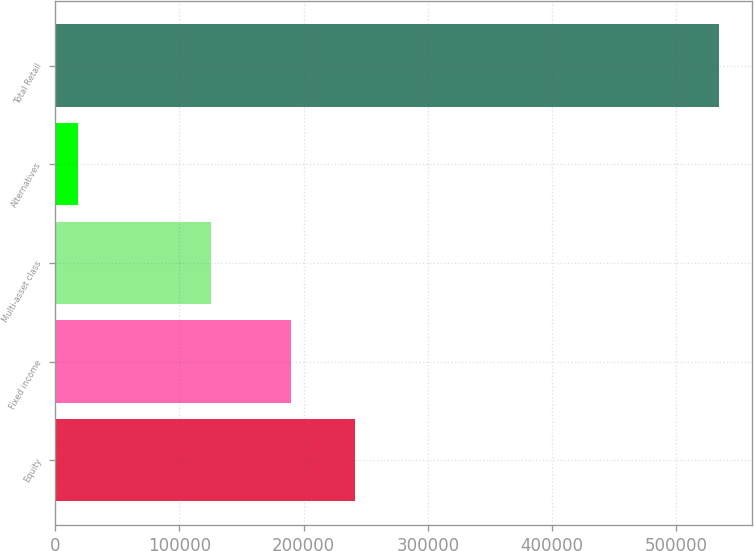<chart> <loc_0><loc_0><loc_500><loc_500><bar_chart><fcel>Equity<fcel>Fixed income<fcel>Multi-asset class<fcel>Alternatives<fcel>Total Retail<nl><fcel>241381<fcel>189820<fcel>125341<fcel>18723<fcel>534329<nl></chart> 